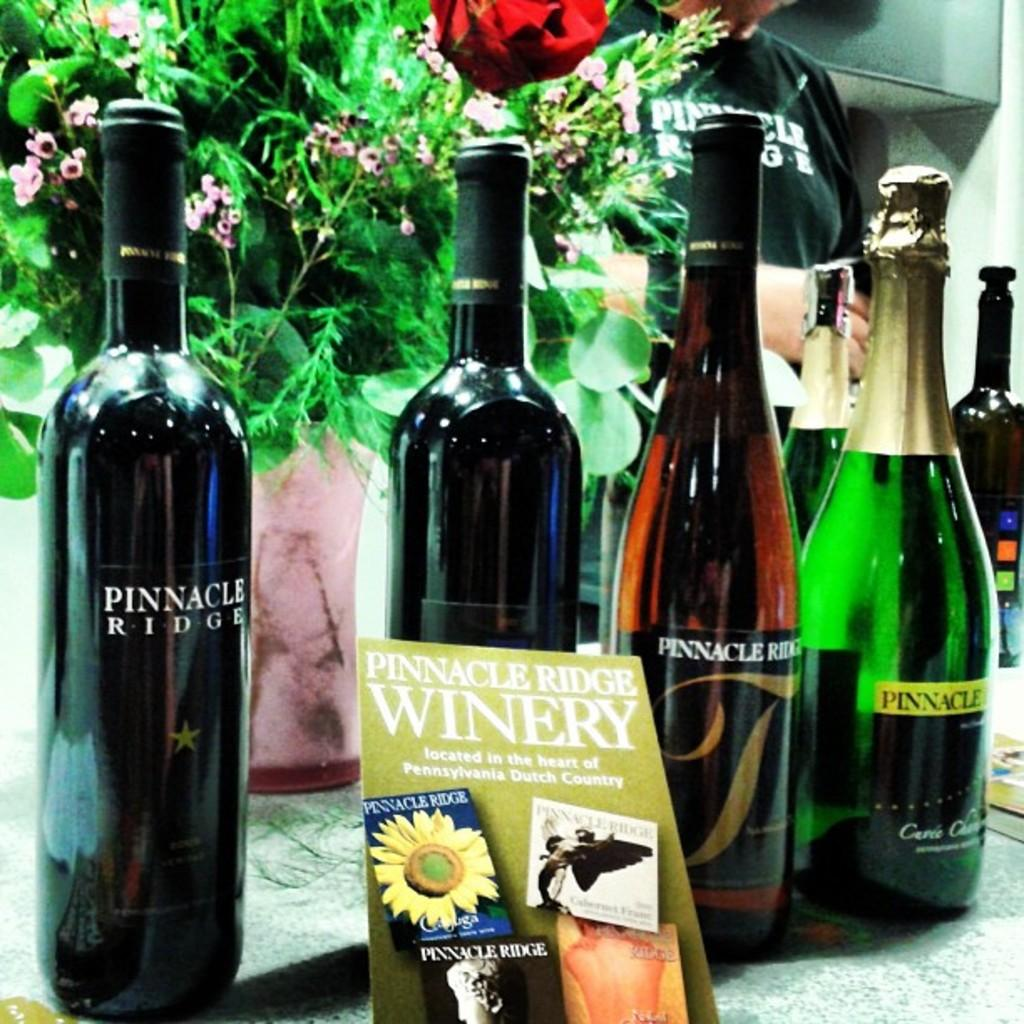Provide a one-sentence caption for the provided image. Bottles of Pinnacle Ridge wine displayed in front of a bunch of flowers. 